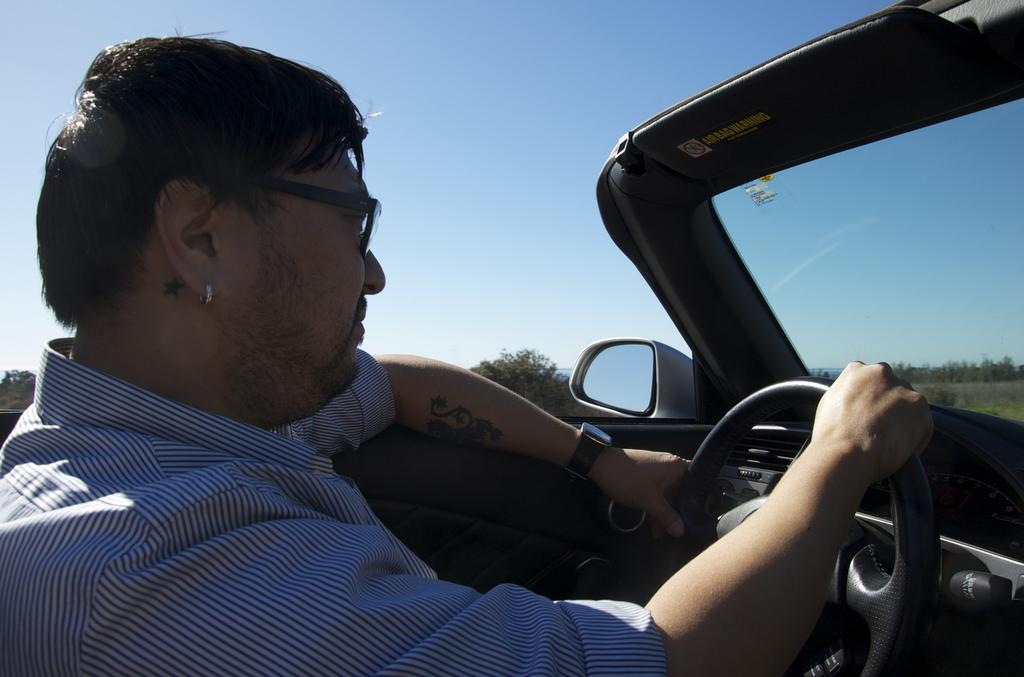What is the main subject of the image? There is a person in the image. What is the person doing in the image? The person is riding a vehicle. What type of natural environment can be seen in the image? There are trees visible in the image. What is visible in the background of the image? The sky is visible in the background of the image. What type of silk fabric is draped over the faucet in the image? There is no faucet or silk fabric present in the image. How does the person pull the vehicle in the image? The person is riding the vehicle, not pulling it, and the image does not provide information on how the vehicle is powered or controlled. 